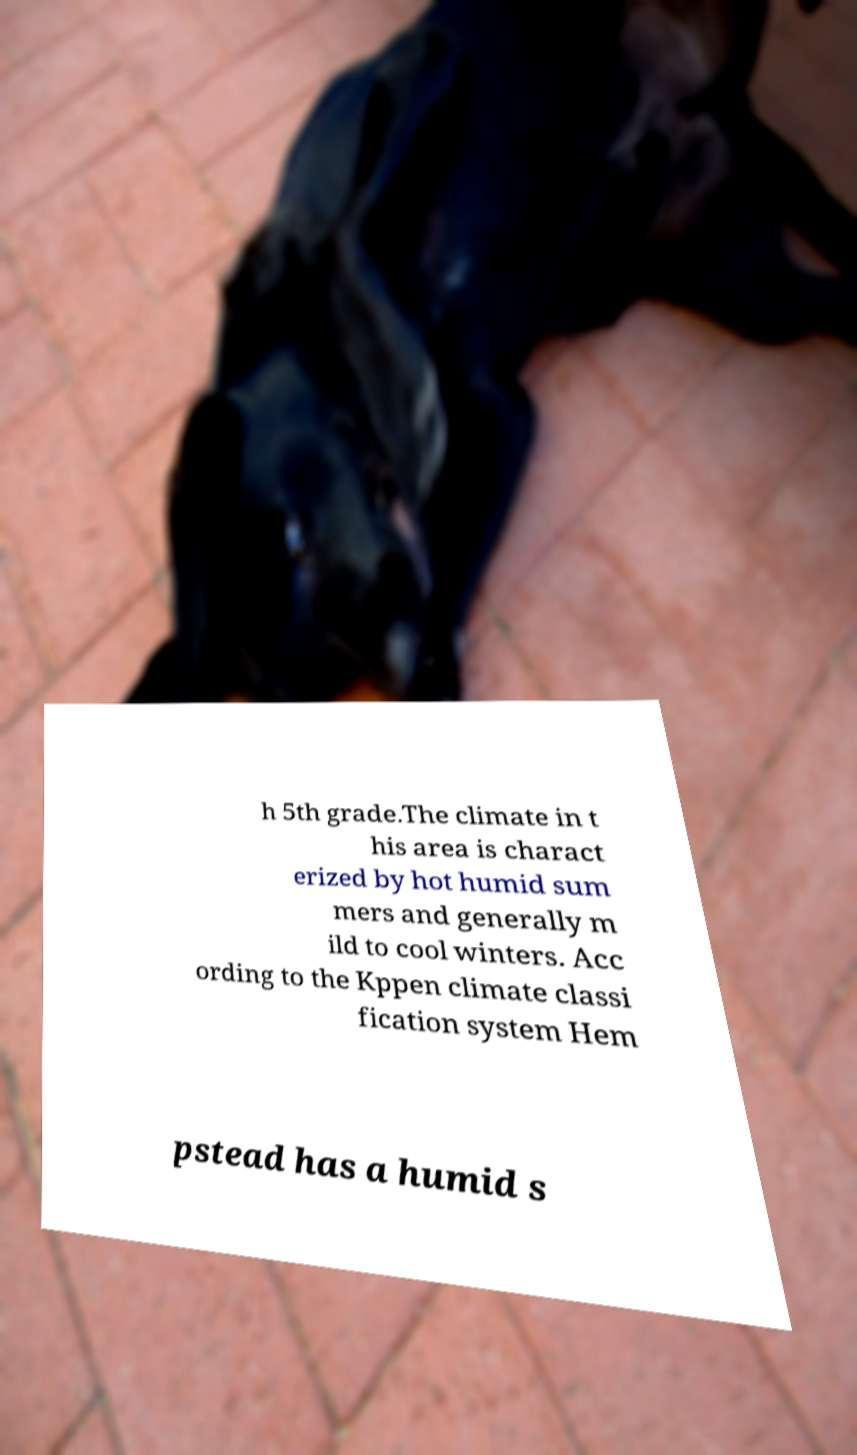There's text embedded in this image that I need extracted. Can you transcribe it verbatim? h 5th grade.The climate in t his area is charact erized by hot humid sum mers and generally m ild to cool winters. Acc ording to the Kppen climate classi fication system Hem pstead has a humid s 